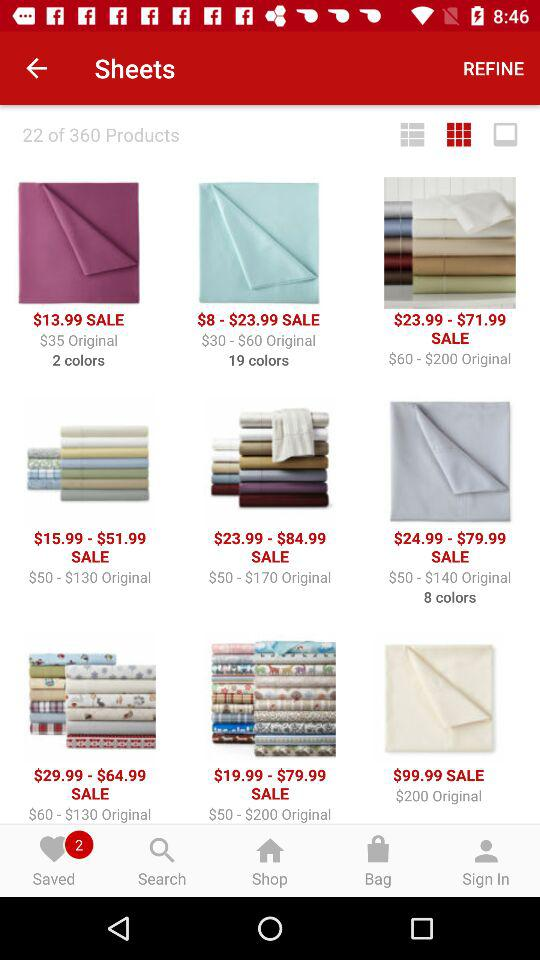On which page number currently are we on?
When the provided information is insufficient, respond with <no answer>. <no answer> 